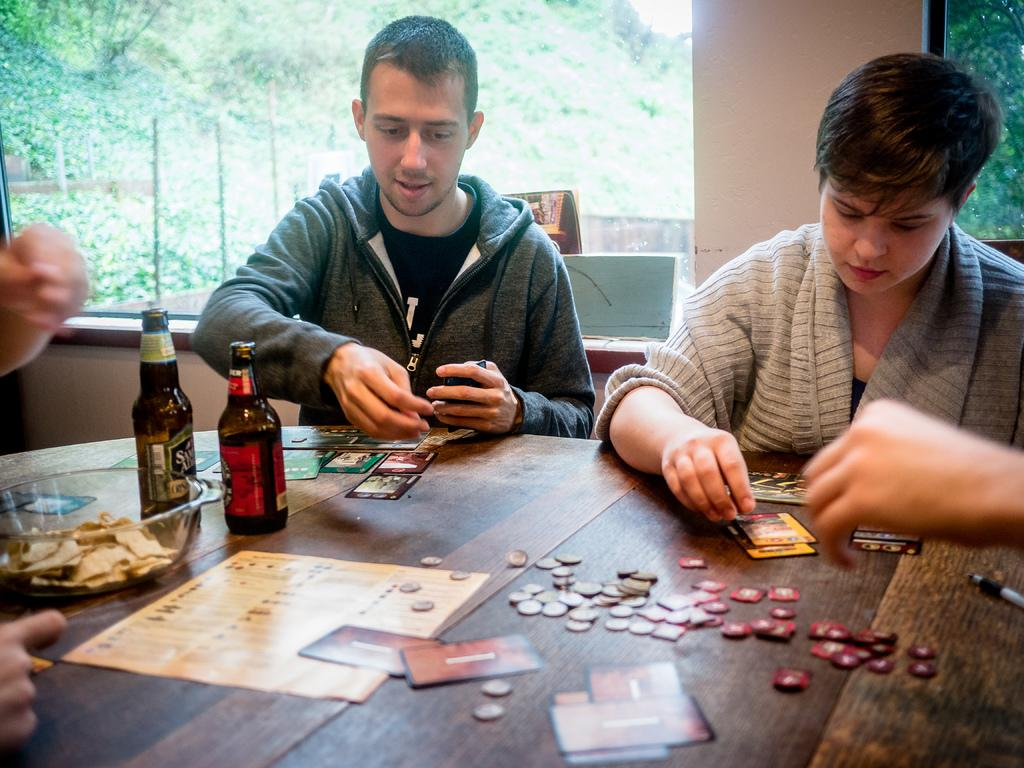How many people are in the image? There are two persons in the image. What are the persons doing in the image? The persons are sitting on chairs. What is in front of the chairs? There is a table in front of the chairs. What can be seen on the table? There are different items on the table. What is visible through the window in the image? Nature is visible through the window. What color is the account on the table in the image? There is no account present in the image; it is a table with different items on it. 